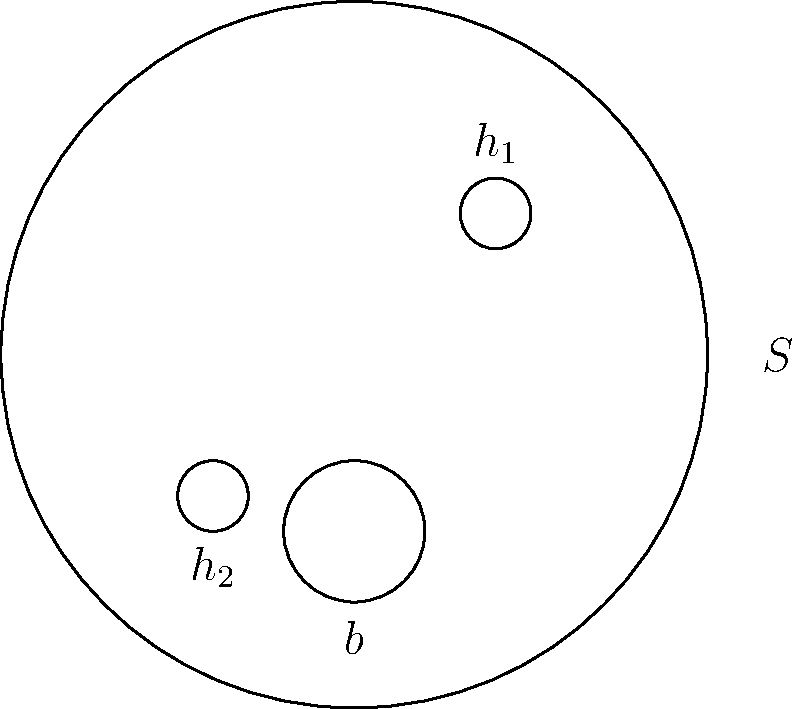Consider the surface $S$ shown in the figure, which has two punctures (labeled $h_1$ and $h_2$) and one boundary component (labeled $b$). What is the fundamental group $\pi_1(S)$ of this surface? To determine the fundamental group of the surface $S$, we'll follow these steps:

1) First, recall that for a surface with genus $g$, $n$ punctures, and $b$ boundary components, the fundamental group is isomorphic to the free group on $2g + n + b$ generators.

2) In this case:
   - The genus $g = 0$ (it's a sphere-like surface)
   - The number of punctures $n = 2$ (labeled $h_1$ and $h_2$)
   - The number of boundary components $b = 1$ (labeled $b$)

3) Therefore, the number of generators for the fundamental group is:
   $2g + n + b = 2(0) + 2 + 1 = 3$

4) Let's call these generators $a$, $b$, and $c$, corresponding to loops around $h_1$, $h_2$, and the boundary component, respectively.

5) The fundamental group is thus the free group on these three generators, which we can write as:

   $\pi_1(S) \cong \langle a, b, c \rangle$

This means that any element of the fundamental group can be written as a word in $a$, $b$, and $c$, and their inverses, with no relations between these generators.
Answer: $\pi_1(S) \cong F_3$ 